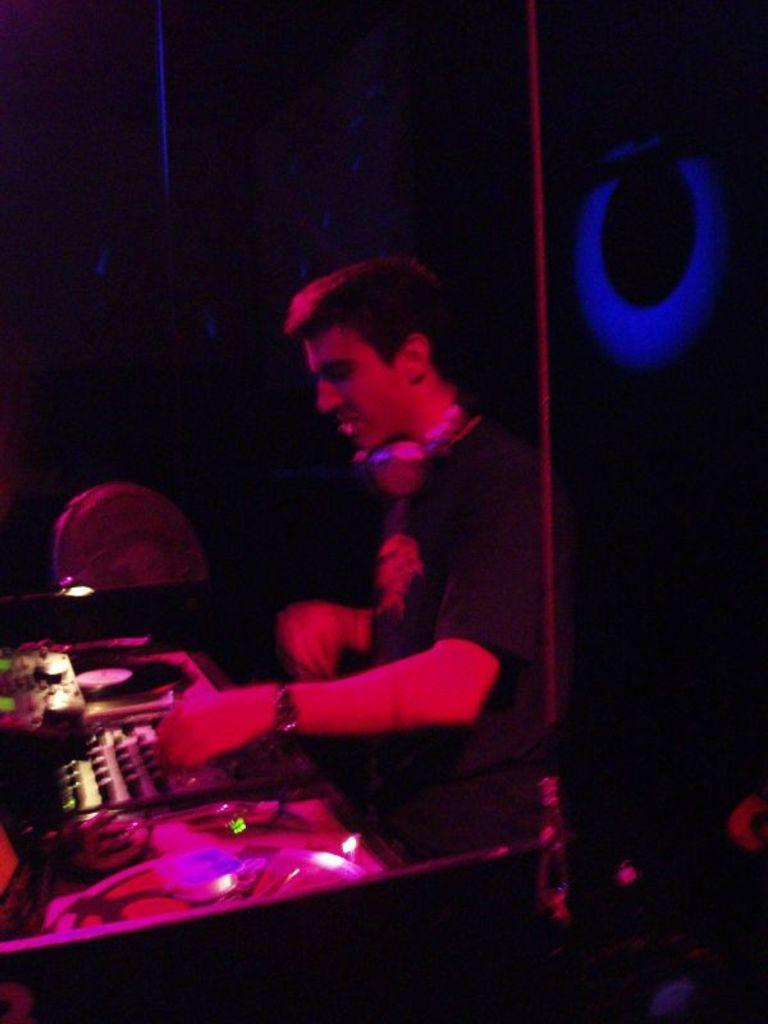What is the man in the image doing? The man is playing the role of a DJ. What is the man wearing in the image? The man is wearing a black T-shirt. How is the man illuminated in the image? Red color light is focused on the man. What is the lighting like in the background of the image? There is dark lighting in the background. What color lights are on the wall behind the man? There are blue color lights on the wall behind the man. What type of whip is the man using to mix the music in the image? There is no whip present in the image; the man is using DJ equipment to mix the music. How many cherries are on the man's shirt in the image? There are no cherries on the man's shirt in the image; he is wearing a black T-shirt. 